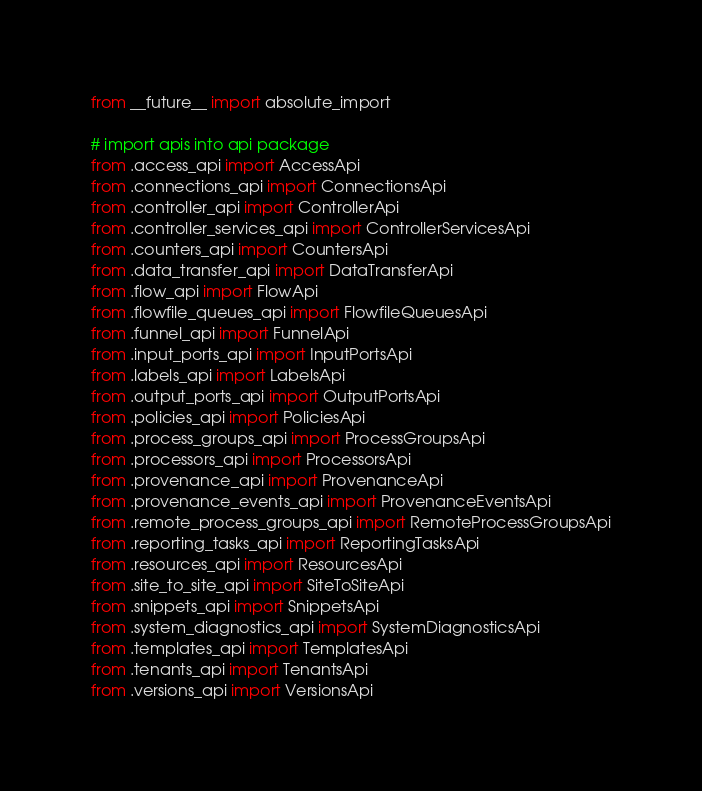<code> <loc_0><loc_0><loc_500><loc_500><_Python_>from __future__ import absolute_import

# import apis into api package
from .access_api import AccessApi
from .connections_api import ConnectionsApi
from .controller_api import ControllerApi
from .controller_services_api import ControllerServicesApi
from .counters_api import CountersApi
from .data_transfer_api import DataTransferApi
from .flow_api import FlowApi
from .flowfile_queues_api import FlowfileQueuesApi
from .funnel_api import FunnelApi
from .input_ports_api import InputPortsApi
from .labels_api import LabelsApi
from .output_ports_api import OutputPortsApi
from .policies_api import PoliciesApi
from .process_groups_api import ProcessGroupsApi
from .processors_api import ProcessorsApi
from .provenance_api import ProvenanceApi
from .provenance_events_api import ProvenanceEventsApi
from .remote_process_groups_api import RemoteProcessGroupsApi
from .reporting_tasks_api import ReportingTasksApi
from .resources_api import ResourcesApi
from .site_to_site_api import SiteToSiteApi
from .snippets_api import SnippetsApi
from .system_diagnostics_api import SystemDiagnosticsApi
from .templates_api import TemplatesApi
from .tenants_api import TenantsApi
from .versions_api import VersionsApi
</code> 